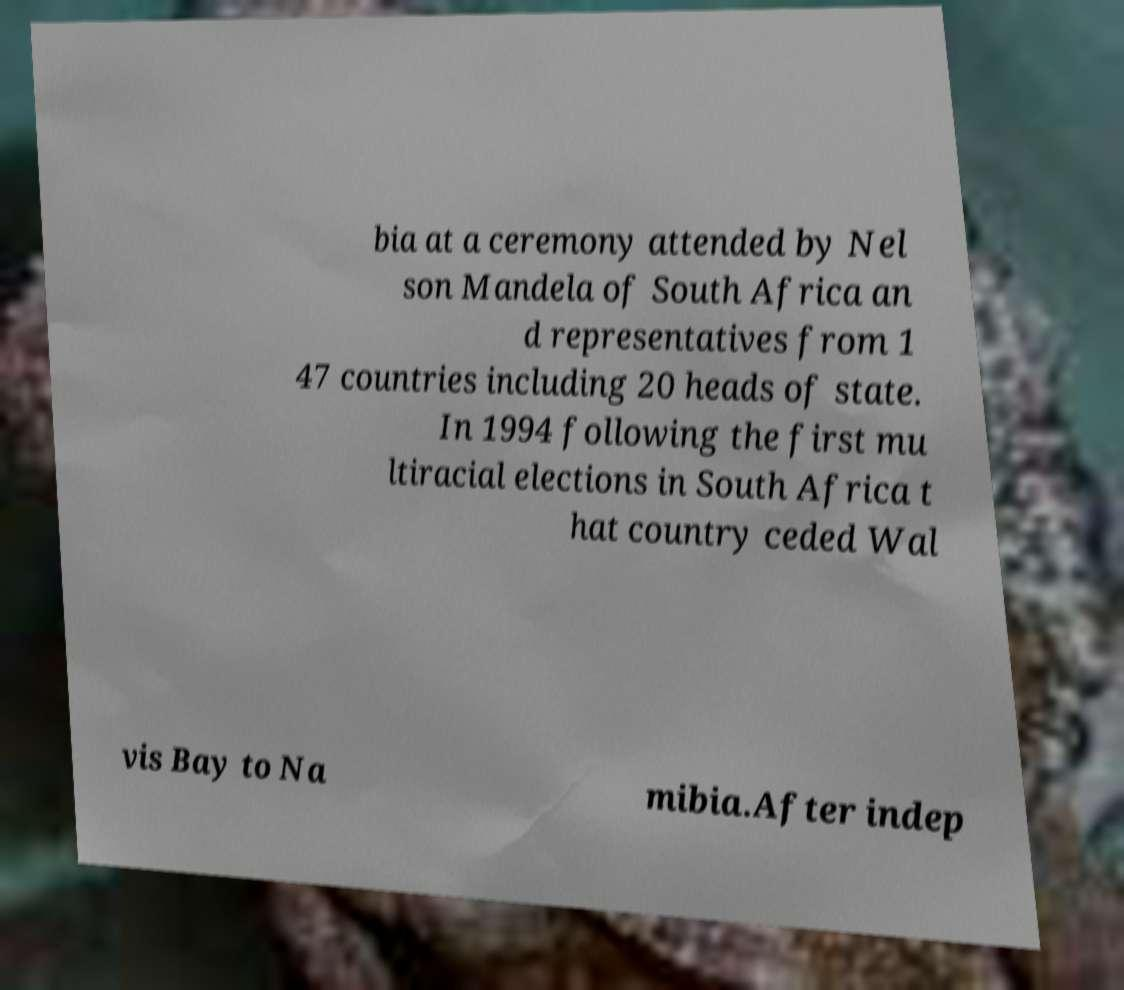Please read and relay the text visible in this image. What does it say? bia at a ceremony attended by Nel son Mandela of South Africa an d representatives from 1 47 countries including 20 heads of state. In 1994 following the first mu ltiracial elections in South Africa t hat country ceded Wal vis Bay to Na mibia.After indep 